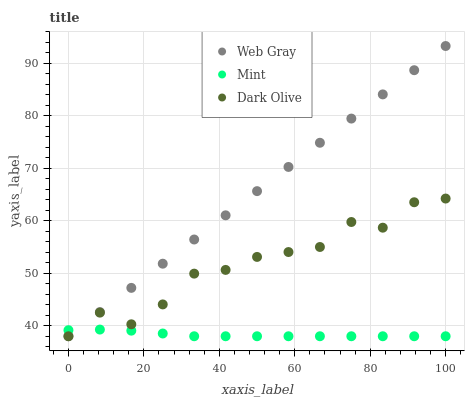Does Mint have the minimum area under the curve?
Answer yes or no. Yes. Does Web Gray have the maximum area under the curve?
Answer yes or no. Yes. Does Web Gray have the minimum area under the curve?
Answer yes or no. No. Does Mint have the maximum area under the curve?
Answer yes or no. No. Is Web Gray the smoothest?
Answer yes or no. Yes. Is Dark Olive the roughest?
Answer yes or no. Yes. Is Mint the smoothest?
Answer yes or no. No. Is Mint the roughest?
Answer yes or no. No. Does Dark Olive have the lowest value?
Answer yes or no. Yes. Does Web Gray have the highest value?
Answer yes or no. Yes. Does Mint have the highest value?
Answer yes or no. No. Does Web Gray intersect Dark Olive?
Answer yes or no. Yes. Is Web Gray less than Dark Olive?
Answer yes or no. No. Is Web Gray greater than Dark Olive?
Answer yes or no. No. 